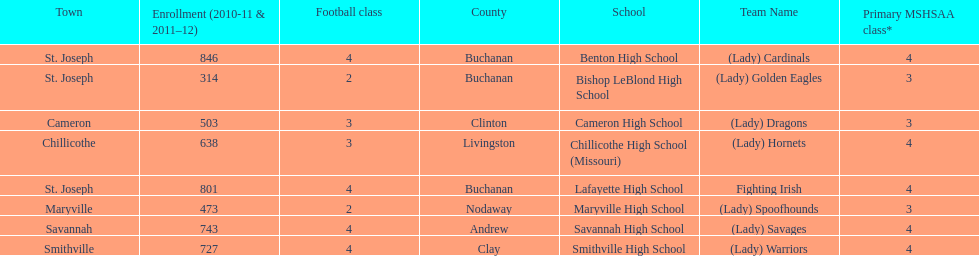Which school has the largest enrollment? Benton High School. 